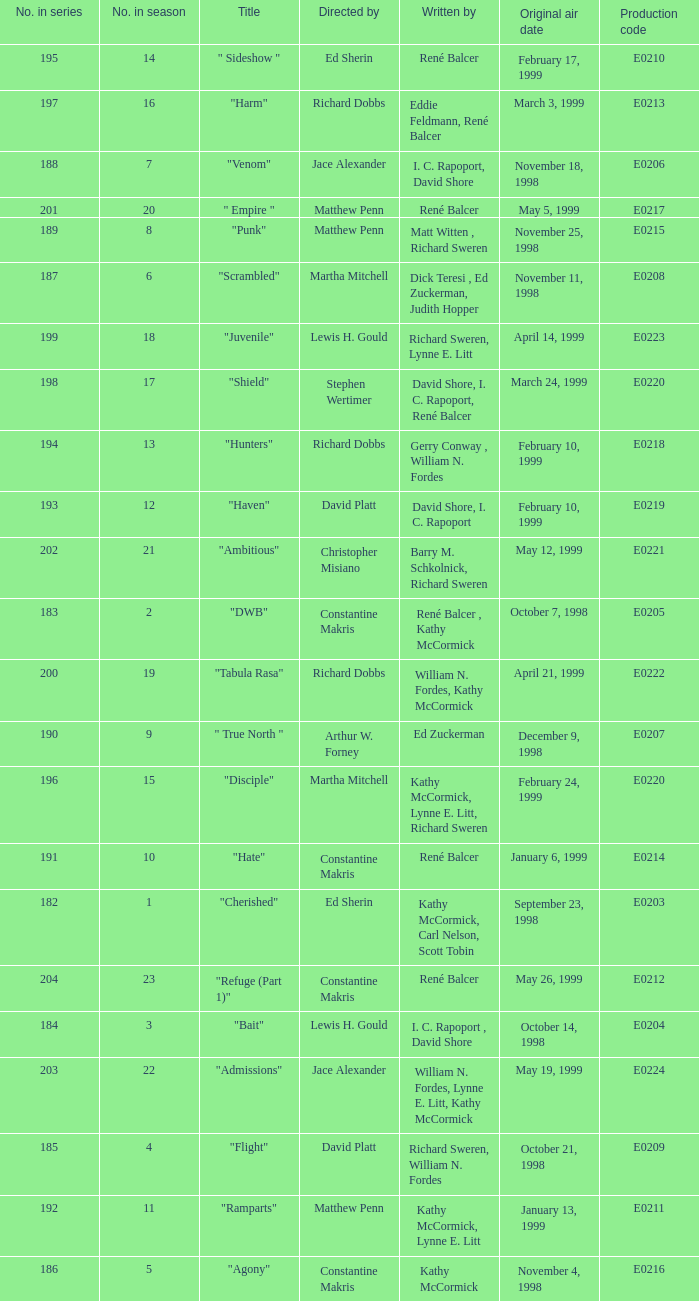What is the title of the episode with the original air date October 21, 1998? "Flight". 